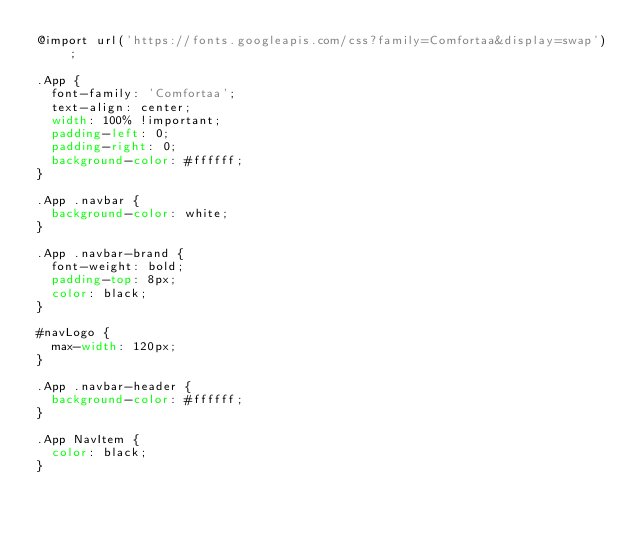Convert code to text. <code><loc_0><loc_0><loc_500><loc_500><_CSS_>@import url('https://fonts.googleapis.com/css?family=Comfortaa&display=swap');

.App {
  font-family: 'Comfortaa';
  text-align: center;
  width: 100% !important;
  padding-left: 0;
  padding-right: 0;
  background-color: #ffffff;
}

.App .navbar {
  background-color: white;
}

.App .navbar-brand {
  font-weight: bold;
  padding-top: 8px;
  color: black;
}

#navLogo {
  max-width: 120px;
}

.App .navbar-header {
  background-color: #ffffff;
}

.App NavItem {
  color: black;
}
</code> 